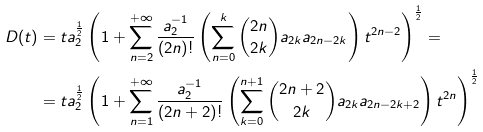Convert formula to latex. <formula><loc_0><loc_0><loc_500><loc_500>D ( t ) & = t a _ { 2 } ^ { \frac { 1 } { 2 } } \left ( 1 + \sum _ { n = 2 } ^ { + \infty } \frac { a _ { 2 } ^ { - 1 } } { \left ( 2 n \right ) ! } \left ( \sum _ { n = 0 } ^ { k } \binom { 2 n } { 2 k } a _ { 2 k } a _ { 2 n - 2 k } \right ) t ^ { 2 n - 2 } \right ) ^ { \frac { 1 } { 2 } } = \\ & = t a _ { 2 } ^ { \frac { 1 } { 2 } } \left ( 1 + \sum _ { n = 1 } ^ { + \infty } \frac { a _ { 2 } ^ { - 1 } } { \left ( 2 n + 2 \right ) ! } \left ( \sum _ { k = 0 } ^ { n + 1 } \binom { 2 n + 2 } { 2 k } a _ { 2 k } a _ { 2 n - 2 k + 2 } \right ) t ^ { 2 n } \right ) ^ { \frac { 1 } { 2 } }</formula> 